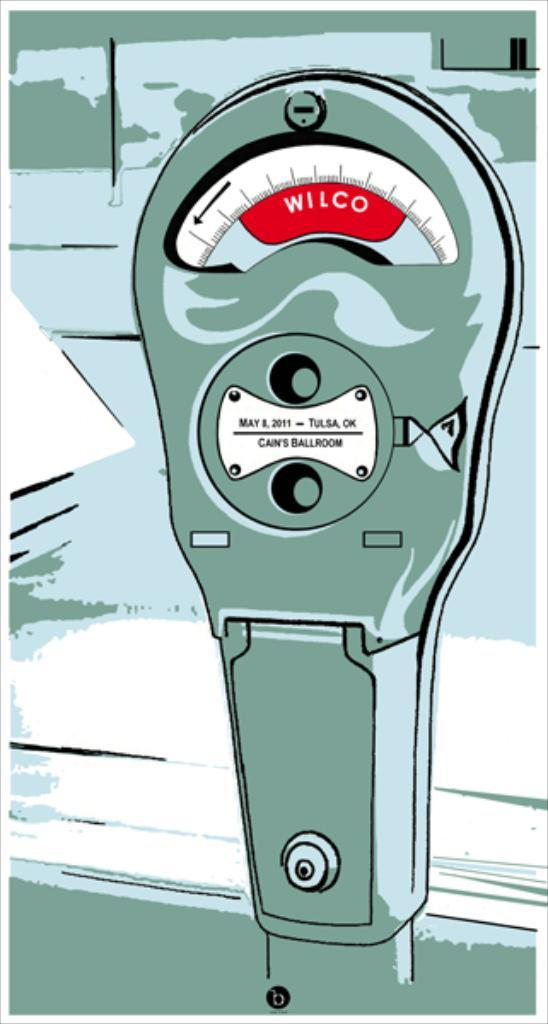<image>
Provide a brief description of the given image. A cartoon of a parking meter that says Tulsa OK on it. 